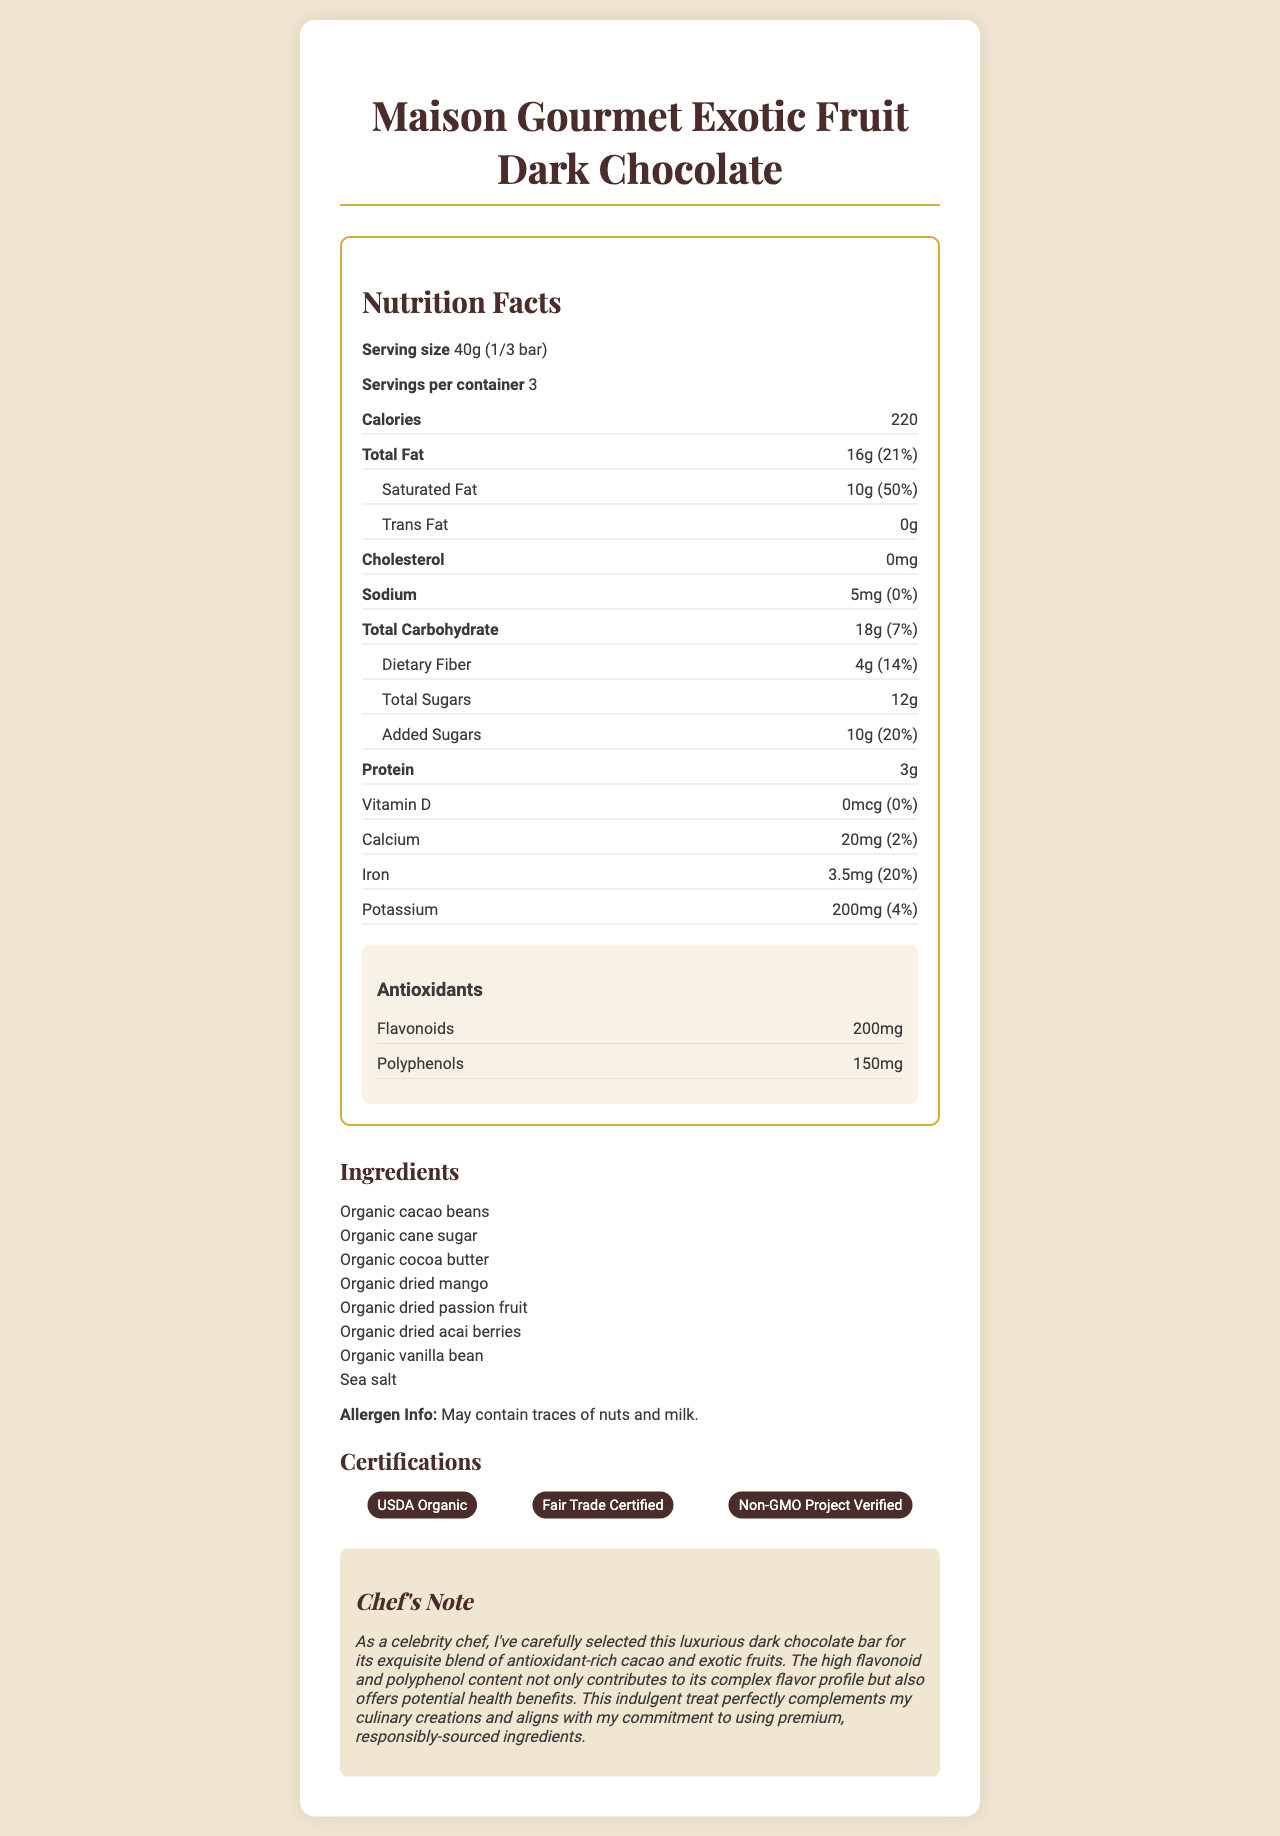what is the serving size? The serving size is explicitly mentioned in the document as "40g (1/3 bar)".
Answer: 40g (1/3 bar) how many calories are in one serving? The document states that there are 220 calories per serving.
Answer: 220 which ingredients are used in the chocolate bar? The ingredients are listed under the "Ingredients" section in the document.
Answer: Organic cacao beans, Organic cane sugar, Organic cocoa butter, Organic dried mango, Organic dried passion fruit, Organic dried acai berries, Organic vanilla bean, Sea salt what is the percentage of daily value for saturated fat? The percentage of daily value for saturated fat is indicated as "50%" in the document.
Answer: 50% how much protein is there in a single serving? The document specifies that there are 3 grams of protein per serving.
Answer: 3g how many servings are there in a container? The servings per container are stated as "3" in the document.
Answer: 3 does the chocolate contain any trans fat? yes/no The document states that the trans fat content is "0g".
Answer: no what certifications does the product have? The certifications are listed in the document under the "Certifications" section.
Answer: USDA Organic, Fair Trade Certified, Non-GMO Project Verified what is the amount of iron present in a serving? The amount of iron per serving is explicitly stated as "3.5mg".
Answer: 3.5mg which of the following is NOT an ingredient in the chocolate bar? A. Organic dried mango B. Organic dried passion fruit C. Dried bananas D. Sea salt The document lists the ingredients, and dried bananas are not mentioned among them.
Answer: C. Dried bananas how many grams of added sugars are there per serving? 1. 5g 2. 8g 3. 10g 4. 12g The amount of added sugars per serving is "10g" as indicated in the document.
Answer: 3. 10g what is the focus of the chef's note? The chef's note details the reasons for selecting the chocolate bar, emphasizing the antioxidant properties, flavor, and high-quality sourcing.
Answer: The chef's note focuses on the selection of the luxurious dark chocolate bar for its blend of antioxidant-rich cacao and exotic fruits, complex flavor profile, and commitment to premium, responsibly-sourced ingredients. how much sodium is in each serving? The document states that there are 5mg of sodium per serving.
Answer: 5mg does the chocolate bar contain any allergens? The allergen information section mentions that the chocolate may contain traces of nuts and milk.
Answer: May contain traces of nuts and milk. can the total number of calories in the entire chocolate bar be determined from the document? By multiplying the calories per serving (220) by the number of servings per container (3), the total number of calories in the entire chocolate bar can be calculated as 220 * 3 = 660 calories.
Answer: Yes does the document provide detailed preparation instructions for the chocolate? yes/no The document does not include any preparation instructions; it only lists nutritional, ingredient, and certification information.
Answer: no describe the main purpose of the document. The main purpose of the document is to provide comprehensive information about the luxury dark chocolate bar, including its nutritional value, ingredients, certifications, and culinary merits as described by a celebrity chef.
Answer: The document presents the nutritional facts, ingredient list, certification details, and chef's note for the "Maison Gourmet Exotic Fruit Dark Chocolate". It highlights the health benefits associated with its high content of antioxidants (flavonoids and polyphenols) and emphasizes its premium, responsibly-sourced ingredients. 